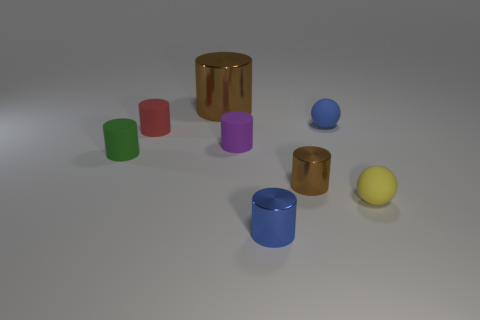What number of other things have the same color as the big thing?
Ensure brevity in your answer.  1. What number of other things are there of the same color as the big cylinder?
Provide a succinct answer. 1. There is another thing that is the same shape as the yellow matte object; what is it made of?
Your answer should be compact. Rubber. Are there fewer metal cylinders right of the purple matte cylinder than metal cylinders?
Keep it short and to the point. Yes. Is the shape of the tiny brown thing in front of the green rubber cylinder the same as  the red matte object?
Give a very brief answer. Yes. What size is the blue object that is made of the same material as the small purple object?
Keep it short and to the point. Small. There is a thing that is behind the tiny blue thing that is to the right of the small shiny object that is right of the small blue shiny object; what is it made of?
Your answer should be compact. Metal. Are there fewer big cylinders than blue things?
Offer a very short reply. Yes. Is the yellow object made of the same material as the tiny blue sphere?
Provide a short and direct response. Yes. What is the shape of the tiny object that is the same color as the large metallic object?
Offer a terse response. Cylinder. 